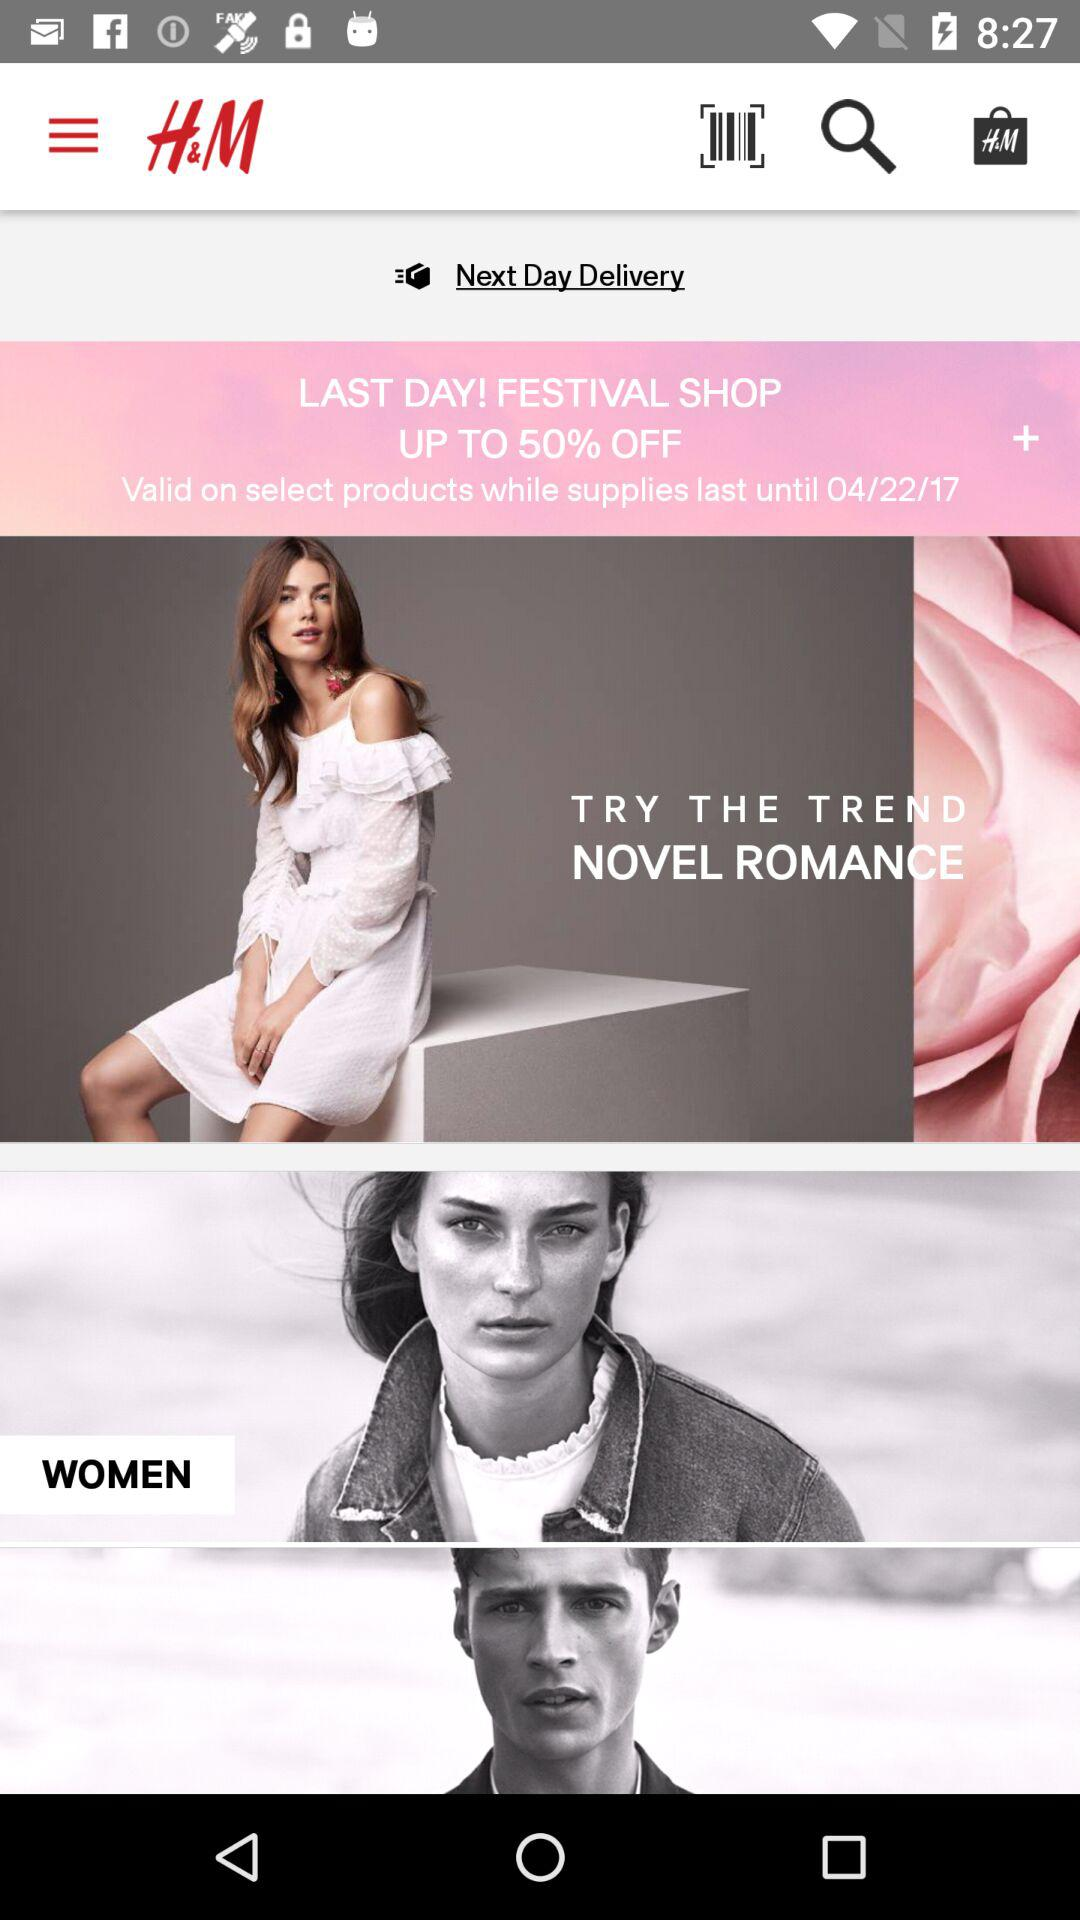What is the name of the application? The name of the application is "H&M". 